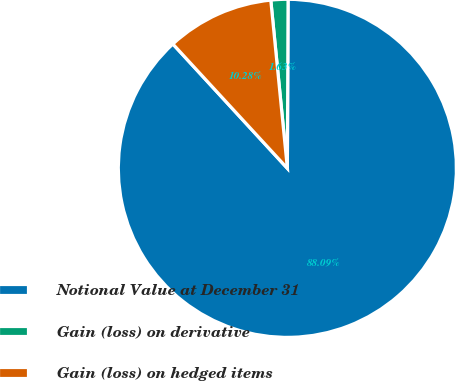<chart> <loc_0><loc_0><loc_500><loc_500><pie_chart><fcel>Notional Value at December 31<fcel>Gain (loss) on derivative<fcel>Gain (loss) on hedged items<nl><fcel>88.09%<fcel>1.63%<fcel>10.28%<nl></chart> 